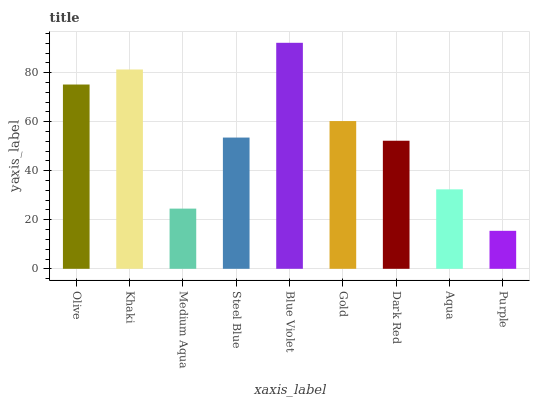Is Purple the minimum?
Answer yes or no. Yes. Is Blue Violet the maximum?
Answer yes or no. Yes. Is Khaki the minimum?
Answer yes or no. No. Is Khaki the maximum?
Answer yes or no. No. Is Khaki greater than Olive?
Answer yes or no. Yes. Is Olive less than Khaki?
Answer yes or no. Yes. Is Olive greater than Khaki?
Answer yes or no. No. Is Khaki less than Olive?
Answer yes or no. No. Is Steel Blue the high median?
Answer yes or no. Yes. Is Steel Blue the low median?
Answer yes or no. Yes. Is Gold the high median?
Answer yes or no. No. Is Dark Red the low median?
Answer yes or no. No. 